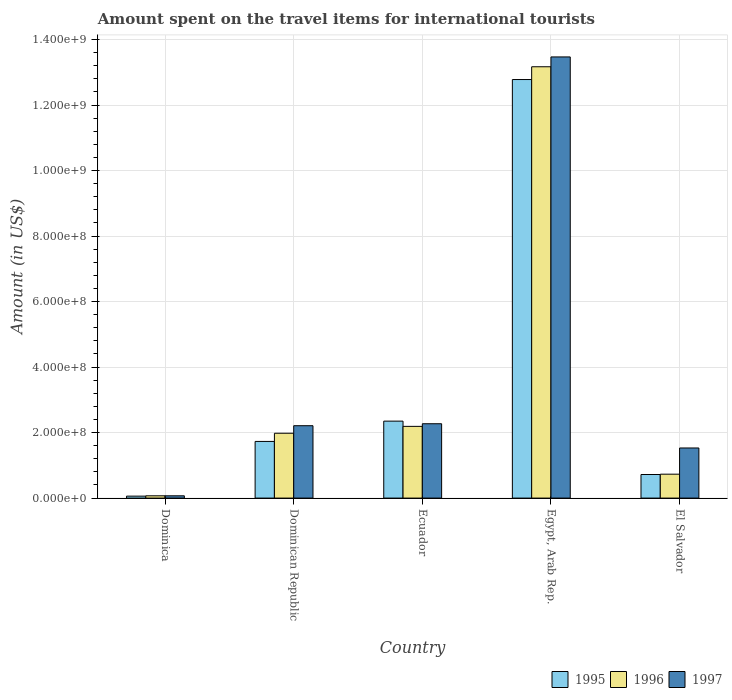How many different coloured bars are there?
Offer a terse response. 3. How many bars are there on the 3rd tick from the left?
Make the answer very short. 3. What is the label of the 1st group of bars from the left?
Provide a succinct answer. Dominica. What is the amount spent on the travel items for international tourists in 1995 in Dominica?
Keep it short and to the point. 6.00e+06. Across all countries, what is the maximum amount spent on the travel items for international tourists in 1996?
Your response must be concise. 1.32e+09. In which country was the amount spent on the travel items for international tourists in 1996 maximum?
Keep it short and to the point. Egypt, Arab Rep. In which country was the amount spent on the travel items for international tourists in 1996 minimum?
Offer a very short reply. Dominica. What is the total amount spent on the travel items for international tourists in 1997 in the graph?
Ensure brevity in your answer.  1.96e+09. What is the difference between the amount spent on the travel items for international tourists in 1997 in Ecuador and that in El Salvador?
Give a very brief answer. 7.40e+07. What is the difference between the amount spent on the travel items for international tourists in 1995 in Dominican Republic and the amount spent on the travel items for international tourists in 1997 in Egypt, Arab Rep.?
Make the answer very short. -1.17e+09. What is the average amount spent on the travel items for international tourists in 1995 per country?
Your answer should be compact. 3.53e+08. What is the ratio of the amount spent on the travel items for international tourists in 1996 in Ecuador to that in Egypt, Arab Rep.?
Your answer should be very brief. 0.17. Is the difference between the amount spent on the travel items for international tourists in 1996 in Dominica and Egypt, Arab Rep. greater than the difference between the amount spent on the travel items for international tourists in 1997 in Dominica and Egypt, Arab Rep.?
Your answer should be very brief. Yes. What is the difference between the highest and the second highest amount spent on the travel items for international tourists in 1996?
Make the answer very short. 1.12e+09. What is the difference between the highest and the lowest amount spent on the travel items for international tourists in 1997?
Your answer should be compact. 1.34e+09. Is the sum of the amount spent on the travel items for international tourists in 1995 in Dominica and Dominican Republic greater than the maximum amount spent on the travel items for international tourists in 1997 across all countries?
Make the answer very short. No. What does the 3rd bar from the left in Dominica represents?
Ensure brevity in your answer.  1997. What does the 1st bar from the right in Ecuador represents?
Provide a short and direct response. 1997. How many bars are there?
Your answer should be compact. 15. Are all the bars in the graph horizontal?
Give a very brief answer. No. How many countries are there in the graph?
Your answer should be very brief. 5. What is the difference between two consecutive major ticks on the Y-axis?
Keep it short and to the point. 2.00e+08. Does the graph contain grids?
Provide a succinct answer. Yes. How are the legend labels stacked?
Your answer should be compact. Horizontal. What is the title of the graph?
Give a very brief answer. Amount spent on the travel items for international tourists. What is the label or title of the X-axis?
Your response must be concise. Country. What is the Amount (in US$) in 1996 in Dominica?
Offer a terse response. 7.00e+06. What is the Amount (in US$) in 1997 in Dominica?
Make the answer very short. 7.00e+06. What is the Amount (in US$) of 1995 in Dominican Republic?
Ensure brevity in your answer.  1.73e+08. What is the Amount (in US$) of 1996 in Dominican Republic?
Provide a succinct answer. 1.98e+08. What is the Amount (in US$) of 1997 in Dominican Republic?
Offer a very short reply. 2.21e+08. What is the Amount (in US$) of 1995 in Ecuador?
Provide a short and direct response. 2.35e+08. What is the Amount (in US$) of 1996 in Ecuador?
Give a very brief answer. 2.19e+08. What is the Amount (in US$) of 1997 in Ecuador?
Your answer should be very brief. 2.27e+08. What is the Amount (in US$) in 1995 in Egypt, Arab Rep.?
Make the answer very short. 1.28e+09. What is the Amount (in US$) of 1996 in Egypt, Arab Rep.?
Provide a short and direct response. 1.32e+09. What is the Amount (in US$) of 1997 in Egypt, Arab Rep.?
Your answer should be compact. 1.35e+09. What is the Amount (in US$) of 1995 in El Salvador?
Make the answer very short. 7.20e+07. What is the Amount (in US$) in 1996 in El Salvador?
Provide a short and direct response. 7.30e+07. What is the Amount (in US$) of 1997 in El Salvador?
Your answer should be very brief. 1.53e+08. Across all countries, what is the maximum Amount (in US$) in 1995?
Your answer should be compact. 1.28e+09. Across all countries, what is the maximum Amount (in US$) in 1996?
Your answer should be very brief. 1.32e+09. Across all countries, what is the maximum Amount (in US$) in 1997?
Provide a short and direct response. 1.35e+09. Across all countries, what is the minimum Amount (in US$) in 1996?
Give a very brief answer. 7.00e+06. What is the total Amount (in US$) in 1995 in the graph?
Your answer should be compact. 1.76e+09. What is the total Amount (in US$) in 1996 in the graph?
Your response must be concise. 1.81e+09. What is the total Amount (in US$) of 1997 in the graph?
Keep it short and to the point. 1.96e+09. What is the difference between the Amount (in US$) in 1995 in Dominica and that in Dominican Republic?
Your answer should be compact. -1.67e+08. What is the difference between the Amount (in US$) of 1996 in Dominica and that in Dominican Republic?
Your response must be concise. -1.91e+08. What is the difference between the Amount (in US$) in 1997 in Dominica and that in Dominican Republic?
Offer a terse response. -2.14e+08. What is the difference between the Amount (in US$) in 1995 in Dominica and that in Ecuador?
Your answer should be compact. -2.29e+08. What is the difference between the Amount (in US$) in 1996 in Dominica and that in Ecuador?
Provide a short and direct response. -2.12e+08. What is the difference between the Amount (in US$) of 1997 in Dominica and that in Ecuador?
Provide a short and direct response. -2.20e+08. What is the difference between the Amount (in US$) in 1995 in Dominica and that in Egypt, Arab Rep.?
Give a very brief answer. -1.27e+09. What is the difference between the Amount (in US$) of 1996 in Dominica and that in Egypt, Arab Rep.?
Your answer should be very brief. -1.31e+09. What is the difference between the Amount (in US$) of 1997 in Dominica and that in Egypt, Arab Rep.?
Your answer should be compact. -1.34e+09. What is the difference between the Amount (in US$) of 1995 in Dominica and that in El Salvador?
Offer a terse response. -6.60e+07. What is the difference between the Amount (in US$) of 1996 in Dominica and that in El Salvador?
Offer a terse response. -6.60e+07. What is the difference between the Amount (in US$) in 1997 in Dominica and that in El Salvador?
Keep it short and to the point. -1.46e+08. What is the difference between the Amount (in US$) of 1995 in Dominican Republic and that in Ecuador?
Keep it short and to the point. -6.20e+07. What is the difference between the Amount (in US$) of 1996 in Dominican Republic and that in Ecuador?
Provide a short and direct response. -2.10e+07. What is the difference between the Amount (in US$) in 1997 in Dominican Republic and that in Ecuador?
Keep it short and to the point. -6.00e+06. What is the difference between the Amount (in US$) of 1995 in Dominican Republic and that in Egypt, Arab Rep.?
Provide a short and direct response. -1.10e+09. What is the difference between the Amount (in US$) of 1996 in Dominican Republic and that in Egypt, Arab Rep.?
Your answer should be very brief. -1.12e+09. What is the difference between the Amount (in US$) of 1997 in Dominican Republic and that in Egypt, Arab Rep.?
Ensure brevity in your answer.  -1.13e+09. What is the difference between the Amount (in US$) of 1995 in Dominican Republic and that in El Salvador?
Make the answer very short. 1.01e+08. What is the difference between the Amount (in US$) in 1996 in Dominican Republic and that in El Salvador?
Your response must be concise. 1.25e+08. What is the difference between the Amount (in US$) in 1997 in Dominican Republic and that in El Salvador?
Offer a terse response. 6.80e+07. What is the difference between the Amount (in US$) of 1995 in Ecuador and that in Egypt, Arab Rep.?
Keep it short and to the point. -1.04e+09. What is the difference between the Amount (in US$) in 1996 in Ecuador and that in Egypt, Arab Rep.?
Your answer should be compact. -1.10e+09. What is the difference between the Amount (in US$) in 1997 in Ecuador and that in Egypt, Arab Rep.?
Your answer should be compact. -1.12e+09. What is the difference between the Amount (in US$) of 1995 in Ecuador and that in El Salvador?
Make the answer very short. 1.63e+08. What is the difference between the Amount (in US$) of 1996 in Ecuador and that in El Salvador?
Offer a terse response. 1.46e+08. What is the difference between the Amount (in US$) of 1997 in Ecuador and that in El Salvador?
Your answer should be very brief. 7.40e+07. What is the difference between the Amount (in US$) in 1995 in Egypt, Arab Rep. and that in El Salvador?
Make the answer very short. 1.21e+09. What is the difference between the Amount (in US$) in 1996 in Egypt, Arab Rep. and that in El Salvador?
Offer a terse response. 1.24e+09. What is the difference between the Amount (in US$) of 1997 in Egypt, Arab Rep. and that in El Salvador?
Your answer should be very brief. 1.19e+09. What is the difference between the Amount (in US$) of 1995 in Dominica and the Amount (in US$) of 1996 in Dominican Republic?
Make the answer very short. -1.92e+08. What is the difference between the Amount (in US$) in 1995 in Dominica and the Amount (in US$) in 1997 in Dominican Republic?
Offer a very short reply. -2.15e+08. What is the difference between the Amount (in US$) in 1996 in Dominica and the Amount (in US$) in 1997 in Dominican Republic?
Make the answer very short. -2.14e+08. What is the difference between the Amount (in US$) in 1995 in Dominica and the Amount (in US$) in 1996 in Ecuador?
Your answer should be compact. -2.13e+08. What is the difference between the Amount (in US$) in 1995 in Dominica and the Amount (in US$) in 1997 in Ecuador?
Provide a succinct answer. -2.21e+08. What is the difference between the Amount (in US$) of 1996 in Dominica and the Amount (in US$) of 1997 in Ecuador?
Ensure brevity in your answer.  -2.20e+08. What is the difference between the Amount (in US$) in 1995 in Dominica and the Amount (in US$) in 1996 in Egypt, Arab Rep.?
Provide a succinct answer. -1.31e+09. What is the difference between the Amount (in US$) in 1995 in Dominica and the Amount (in US$) in 1997 in Egypt, Arab Rep.?
Give a very brief answer. -1.34e+09. What is the difference between the Amount (in US$) in 1996 in Dominica and the Amount (in US$) in 1997 in Egypt, Arab Rep.?
Offer a very short reply. -1.34e+09. What is the difference between the Amount (in US$) of 1995 in Dominica and the Amount (in US$) of 1996 in El Salvador?
Your answer should be compact. -6.70e+07. What is the difference between the Amount (in US$) in 1995 in Dominica and the Amount (in US$) in 1997 in El Salvador?
Give a very brief answer. -1.47e+08. What is the difference between the Amount (in US$) in 1996 in Dominica and the Amount (in US$) in 1997 in El Salvador?
Give a very brief answer. -1.46e+08. What is the difference between the Amount (in US$) in 1995 in Dominican Republic and the Amount (in US$) in 1996 in Ecuador?
Your answer should be very brief. -4.60e+07. What is the difference between the Amount (in US$) of 1995 in Dominican Republic and the Amount (in US$) of 1997 in Ecuador?
Your response must be concise. -5.40e+07. What is the difference between the Amount (in US$) in 1996 in Dominican Republic and the Amount (in US$) in 1997 in Ecuador?
Make the answer very short. -2.90e+07. What is the difference between the Amount (in US$) in 1995 in Dominican Republic and the Amount (in US$) in 1996 in Egypt, Arab Rep.?
Make the answer very short. -1.14e+09. What is the difference between the Amount (in US$) of 1995 in Dominican Republic and the Amount (in US$) of 1997 in Egypt, Arab Rep.?
Provide a succinct answer. -1.17e+09. What is the difference between the Amount (in US$) of 1996 in Dominican Republic and the Amount (in US$) of 1997 in Egypt, Arab Rep.?
Ensure brevity in your answer.  -1.15e+09. What is the difference between the Amount (in US$) in 1996 in Dominican Republic and the Amount (in US$) in 1997 in El Salvador?
Ensure brevity in your answer.  4.50e+07. What is the difference between the Amount (in US$) in 1995 in Ecuador and the Amount (in US$) in 1996 in Egypt, Arab Rep.?
Your response must be concise. -1.08e+09. What is the difference between the Amount (in US$) of 1995 in Ecuador and the Amount (in US$) of 1997 in Egypt, Arab Rep.?
Offer a terse response. -1.11e+09. What is the difference between the Amount (in US$) in 1996 in Ecuador and the Amount (in US$) in 1997 in Egypt, Arab Rep.?
Make the answer very short. -1.13e+09. What is the difference between the Amount (in US$) of 1995 in Ecuador and the Amount (in US$) of 1996 in El Salvador?
Provide a succinct answer. 1.62e+08. What is the difference between the Amount (in US$) in 1995 in Ecuador and the Amount (in US$) in 1997 in El Salvador?
Make the answer very short. 8.20e+07. What is the difference between the Amount (in US$) in 1996 in Ecuador and the Amount (in US$) in 1997 in El Salvador?
Make the answer very short. 6.60e+07. What is the difference between the Amount (in US$) in 1995 in Egypt, Arab Rep. and the Amount (in US$) in 1996 in El Salvador?
Give a very brief answer. 1.20e+09. What is the difference between the Amount (in US$) in 1995 in Egypt, Arab Rep. and the Amount (in US$) in 1997 in El Salvador?
Keep it short and to the point. 1.12e+09. What is the difference between the Amount (in US$) of 1996 in Egypt, Arab Rep. and the Amount (in US$) of 1997 in El Salvador?
Give a very brief answer. 1.16e+09. What is the average Amount (in US$) in 1995 per country?
Ensure brevity in your answer.  3.53e+08. What is the average Amount (in US$) of 1996 per country?
Make the answer very short. 3.63e+08. What is the average Amount (in US$) of 1997 per country?
Offer a very short reply. 3.91e+08. What is the difference between the Amount (in US$) in 1995 and Amount (in US$) in 1996 in Dominica?
Give a very brief answer. -1.00e+06. What is the difference between the Amount (in US$) in 1995 and Amount (in US$) in 1997 in Dominica?
Offer a very short reply. -1.00e+06. What is the difference between the Amount (in US$) in 1996 and Amount (in US$) in 1997 in Dominica?
Provide a short and direct response. 0. What is the difference between the Amount (in US$) of 1995 and Amount (in US$) of 1996 in Dominican Republic?
Provide a short and direct response. -2.50e+07. What is the difference between the Amount (in US$) in 1995 and Amount (in US$) in 1997 in Dominican Republic?
Keep it short and to the point. -4.80e+07. What is the difference between the Amount (in US$) of 1996 and Amount (in US$) of 1997 in Dominican Republic?
Your answer should be very brief. -2.30e+07. What is the difference between the Amount (in US$) in 1995 and Amount (in US$) in 1996 in Ecuador?
Provide a short and direct response. 1.60e+07. What is the difference between the Amount (in US$) in 1995 and Amount (in US$) in 1997 in Ecuador?
Give a very brief answer. 8.00e+06. What is the difference between the Amount (in US$) in 1996 and Amount (in US$) in 1997 in Ecuador?
Offer a very short reply. -8.00e+06. What is the difference between the Amount (in US$) in 1995 and Amount (in US$) in 1996 in Egypt, Arab Rep.?
Make the answer very short. -3.90e+07. What is the difference between the Amount (in US$) of 1995 and Amount (in US$) of 1997 in Egypt, Arab Rep.?
Give a very brief answer. -6.90e+07. What is the difference between the Amount (in US$) in 1996 and Amount (in US$) in 1997 in Egypt, Arab Rep.?
Your answer should be very brief. -3.00e+07. What is the difference between the Amount (in US$) of 1995 and Amount (in US$) of 1997 in El Salvador?
Give a very brief answer. -8.10e+07. What is the difference between the Amount (in US$) in 1996 and Amount (in US$) in 1997 in El Salvador?
Make the answer very short. -8.00e+07. What is the ratio of the Amount (in US$) in 1995 in Dominica to that in Dominican Republic?
Your answer should be compact. 0.03. What is the ratio of the Amount (in US$) in 1996 in Dominica to that in Dominican Republic?
Make the answer very short. 0.04. What is the ratio of the Amount (in US$) of 1997 in Dominica to that in Dominican Republic?
Offer a terse response. 0.03. What is the ratio of the Amount (in US$) in 1995 in Dominica to that in Ecuador?
Make the answer very short. 0.03. What is the ratio of the Amount (in US$) of 1996 in Dominica to that in Ecuador?
Provide a short and direct response. 0.03. What is the ratio of the Amount (in US$) in 1997 in Dominica to that in Ecuador?
Offer a very short reply. 0.03. What is the ratio of the Amount (in US$) in 1995 in Dominica to that in Egypt, Arab Rep.?
Make the answer very short. 0. What is the ratio of the Amount (in US$) in 1996 in Dominica to that in Egypt, Arab Rep.?
Offer a very short reply. 0.01. What is the ratio of the Amount (in US$) of 1997 in Dominica to that in Egypt, Arab Rep.?
Provide a short and direct response. 0.01. What is the ratio of the Amount (in US$) of 1995 in Dominica to that in El Salvador?
Your answer should be compact. 0.08. What is the ratio of the Amount (in US$) in 1996 in Dominica to that in El Salvador?
Your response must be concise. 0.1. What is the ratio of the Amount (in US$) in 1997 in Dominica to that in El Salvador?
Your answer should be very brief. 0.05. What is the ratio of the Amount (in US$) in 1995 in Dominican Republic to that in Ecuador?
Ensure brevity in your answer.  0.74. What is the ratio of the Amount (in US$) in 1996 in Dominican Republic to that in Ecuador?
Provide a succinct answer. 0.9. What is the ratio of the Amount (in US$) of 1997 in Dominican Republic to that in Ecuador?
Your response must be concise. 0.97. What is the ratio of the Amount (in US$) of 1995 in Dominican Republic to that in Egypt, Arab Rep.?
Your response must be concise. 0.14. What is the ratio of the Amount (in US$) of 1996 in Dominican Republic to that in Egypt, Arab Rep.?
Your response must be concise. 0.15. What is the ratio of the Amount (in US$) of 1997 in Dominican Republic to that in Egypt, Arab Rep.?
Offer a very short reply. 0.16. What is the ratio of the Amount (in US$) in 1995 in Dominican Republic to that in El Salvador?
Offer a terse response. 2.4. What is the ratio of the Amount (in US$) of 1996 in Dominican Republic to that in El Salvador?
Provide a short and direct response. 2.71. What is the ratio of the Amount (in US$) in 1997 in Dominican Republic to that in El Salvador?
Offer a very short reply. 1.44. What is the ratio of the Amount (in US$) of 1995 in Ecuador to that in Egypt, Arab Rep.?
Offer a very short reply. 0.18. What is the ratio of the Amount (in US$) of 1996 in Ecuador to that in Egypt, Arab Rep.?
Keep it short and to the point. 0.17. What is the ratio of the Amount (in US$) in 1997 in Ecuador to that in Egypt, Arab Rep.?
Offer a terse response. 0.17. What is the ratio of the Amount (in US$) in 1995 in Ecuador to that in El Salvador?
Offer a terse response. 3.26. What is the ratio of the Amount (in US$) in 1997 in Ecuador to that in El Salvador?
Ensure brevity in your answer.  1.48. What is the ratio of the Amount (in US$) of 1995 in Egypt, Arab Rep. to that in El Salvador?
Your answer should be compact. 17.75. What is the ratio of the Amount (in US$) in 1996 in Egypt, Arab Rep. to that in El Salvador?
Your response must be concise. 18.04. What is the ratio of the Amount (in US$) in 1997 in Egypt, Arab Rep. to that in El Salvador?
Offer a very short reply. 8.8. What is the difference between the highest and the second highest Amount (in US$) of 1995?
Make the answer very short. 1.04e+09. What is the difference between the highest and the second highest Amount (in US$) in 1996?
Your answer should be compact. 1.10e+09. What is the difference between the highest and the second highest Amount (in US$) of 1997?
Keep it short and to the point. 1.12e+09. What is the difference between the highest and the lowest Amount (in US$) in 1995?
Keep it short and to the point. 1.27e+09. What is the difference between the highest and the lowest Amount (in US$) of 1996?
Make the answer very short. 1.31e+09. What is the difference between the highest and the lowest Amount (in US$) in 1997?
Your response must be concise. 1.34e+09. 